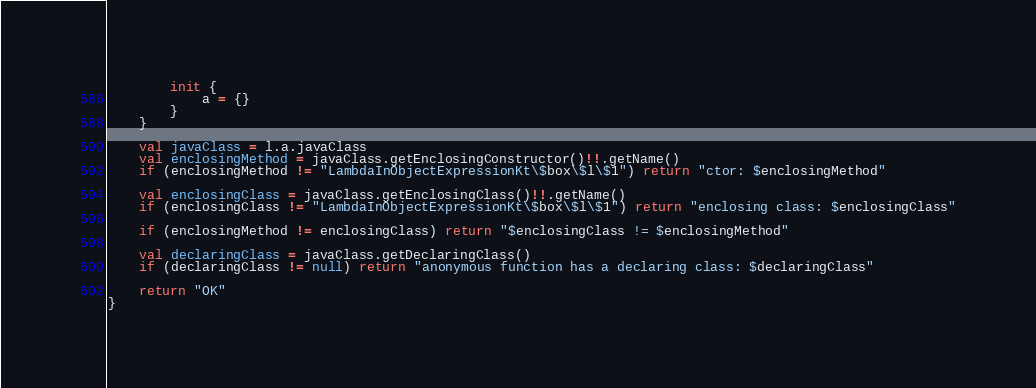Convert code to text. <code><loc_0><loc_0><loc_500><loc_500><_Kotlin_>        init {
            a = {}
        }
    }

    val javaClass = l.a.javaClass
    val enclosingMethod = javaClass.getEnclosingConstructor()!!.getName()
    if (enclosingMethod != "LambdaInObjectExpressionKt\$box\$l\$1") return "ctor: $enclosingMethod"

    val enclosingClass = javaClass.getEnclosingClass()!!.getName()
    if (enclosingClass != "LambdaInObjectExpressionKt\$box\$l\$1") return "enclosing class: $enclosingClass"

    if (enclosingMethod != enclosingClass) return "$enclosingClass != $enclosingMethod"

    val declaringClass = javaClass.getDeclaringClass()
    if (declaringClass != null) return "anonymous function has a declaring class: $declaringClass"

    return "OK"
}
</code> 